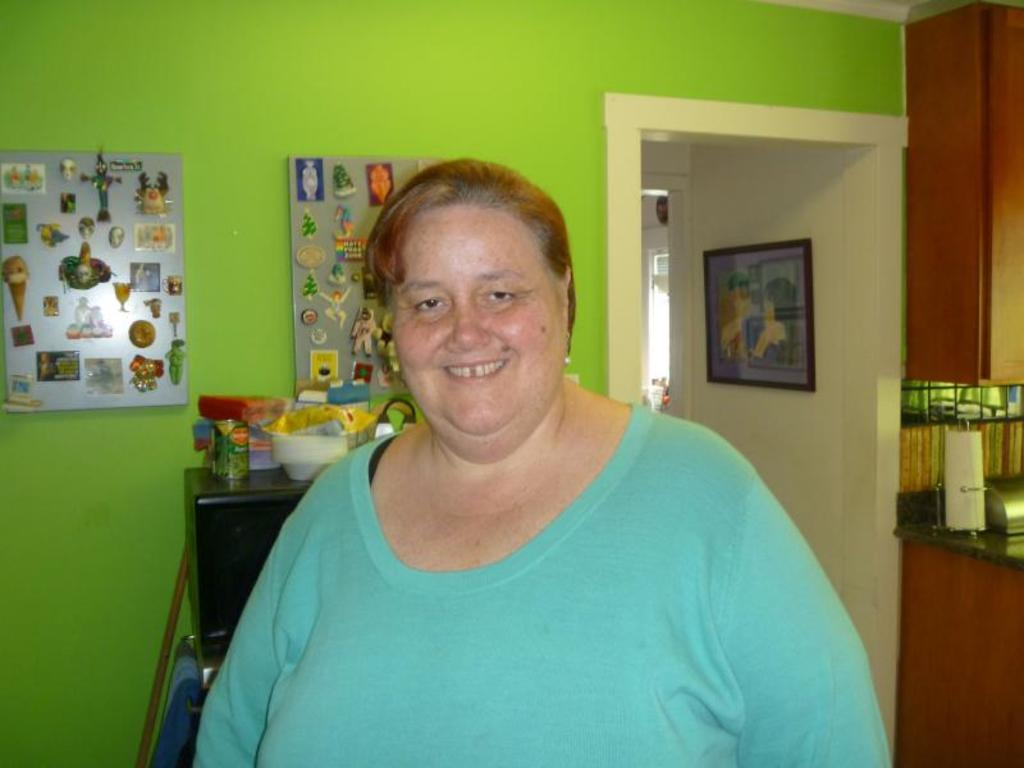What is the main subject of the image? There is a woman standing in the image. Where is the woman standing? The woman is standing on the floor. What can be seen in the background of the image? There are boards, a microwave oven, some objects, a door, a photo frame, and tissues present in the background of the image. What type of approval is the woman seeking in the image? There is no indication in the image that the woman is seeking any approval. Is there a maid present in the image? There is no mention of a maid in the image or the provided facts. 